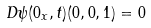<formula> <loc_0><loc_0><loc_500><loc_500>D \psi ( 0 _ { x } , t ) ( 0 , 0 , 1 ) = 0</formula> 